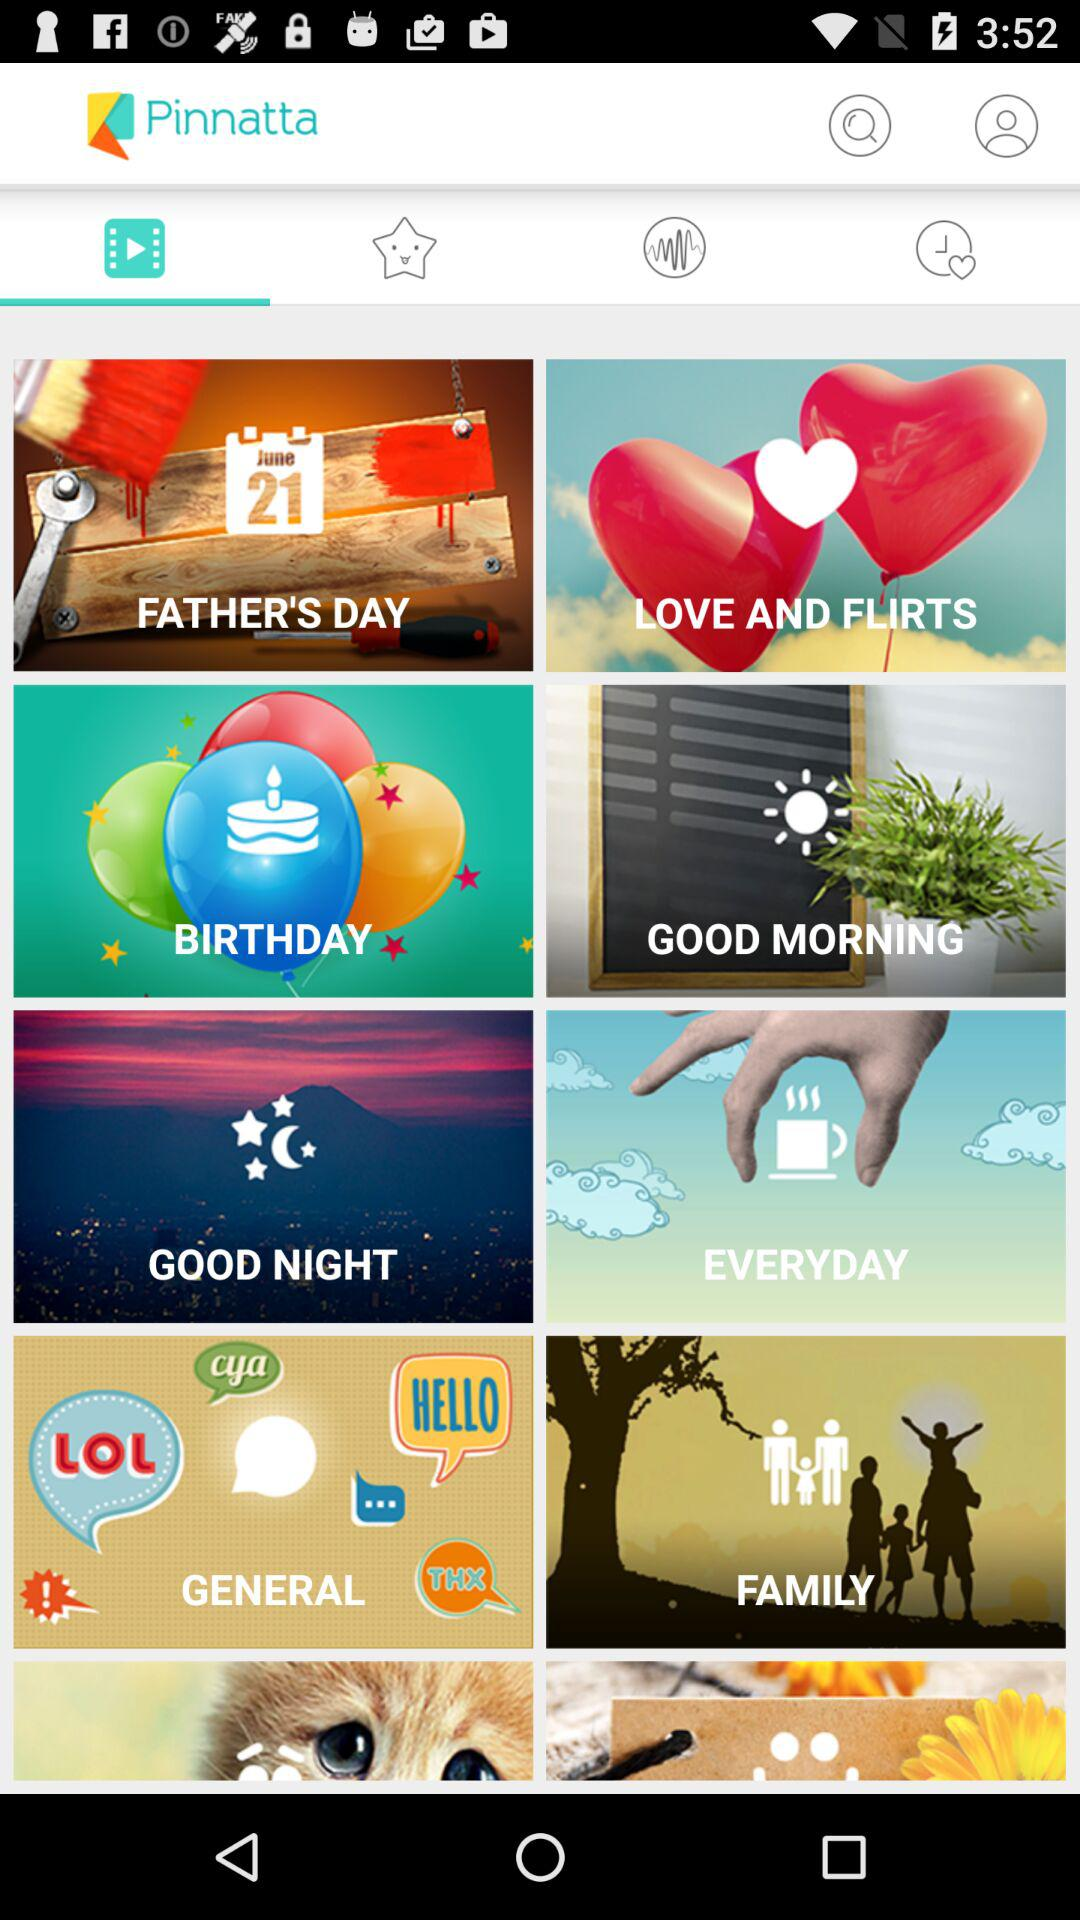What are the different shown categories? The different shown categories are "FATHER'S DAY", "LOVE AND FLIRTS", "BIRTHDAY", "GOOD MORNING", "GOOD NIGHT", "EVERYDAY", "GENERAL" and "FAMILY". 